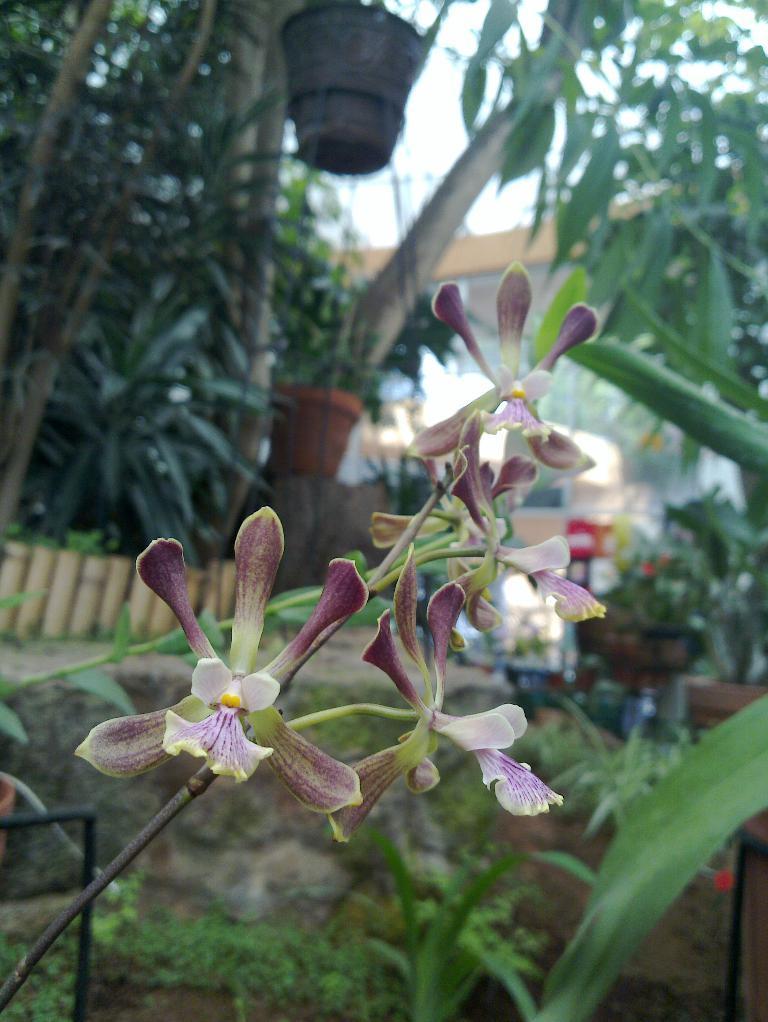In one or two sentences, can you explain what this image depicts? In the foreground of the picture there are flowers and stems. At the bottom we can see plants. In the background there are trees, fencing, building, path and other objects. 